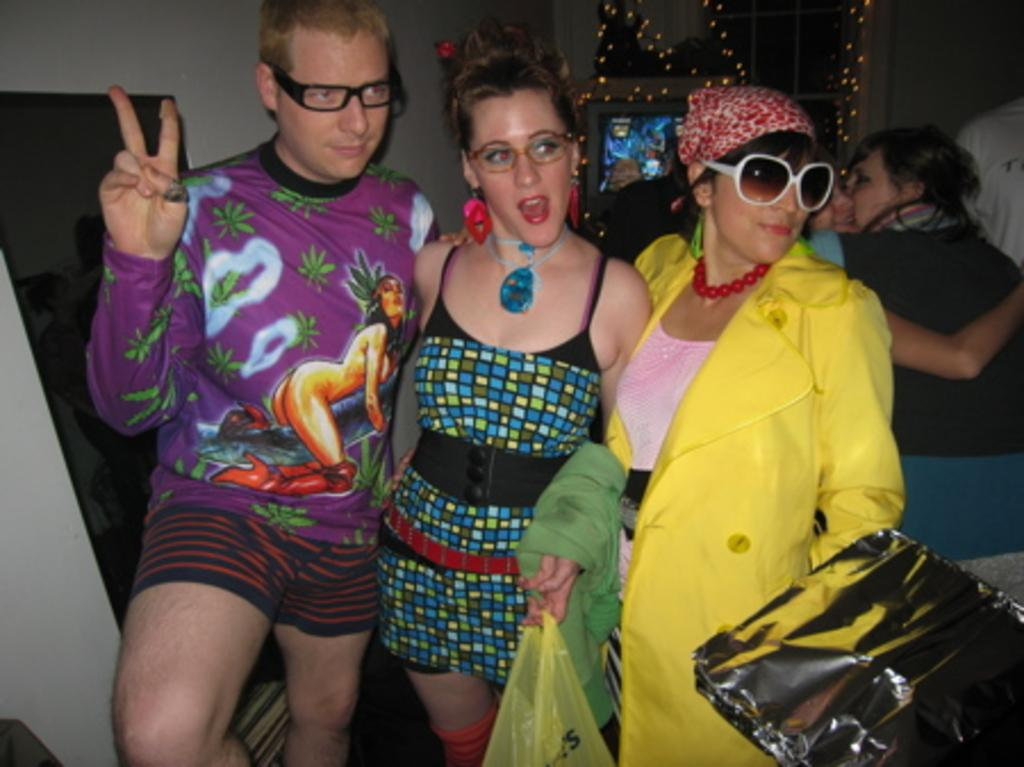How many people are present in the image? There are three people standing in the image. What is the middle woman holding? The middle woman is holding a cover and cloth. What can be seen in the background of the image? There is a wall, people, and decorative lights in the background of the image. What type of fruit is being served by the rabbits in the image? There are no rabbits or fruit present in the image. What fictional character can be seen interacting with the people in the image? There are no fictional characters depicted in the image. 